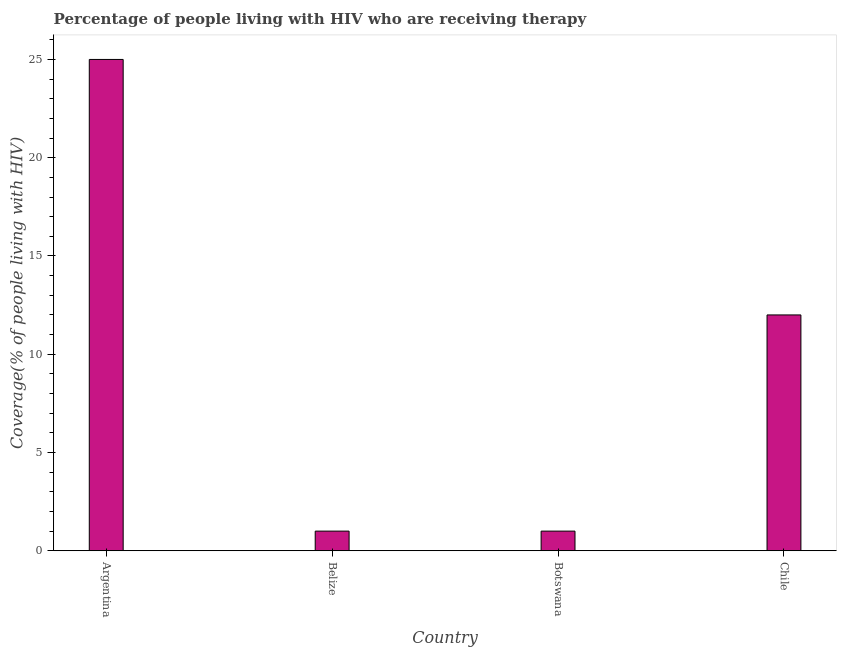Does the graph contain any zero values?
Offer a terse response. No. What is the title of the graph?
Your answer should be compact. Percentage of people living with HIV who are receiving therapy. What is the label or title of the X-axis?
Make the answer very short. Country. What is the label or title of the Y-axis?
Offer a very short reply. Coverage(% of people living with HIV). Across all countries, what is the maximum antiretroviral therapy coverage?
Provide a succinct answer. 25. Across all countries, what is the minimum antiretroviral therapy coverage?
Keep it short and to the point. 1. In which country was the antiretroviral therapy coverage maximum?
Provide a succinct answer. Argentina. In which country was the antiretroviral therapy coverage minimum?
Provide a short and direct response. Belize. What is the sum of the antiretroviral therapy coverage?
Your response must be concise. 39. What is the difference between the antiretroviral therapy coverage in Botswana and Chile?
Offer a terse response. -11. What is the average antiretroviral therapy coverage per country?
Keep it short and to the point. 9.75. In how many countries, is the antiretroviral therapy coverage greater than 22 %?
Offer a very short reply. 1. What is the ratio of the antiretroviral therapy coverage in Botswana to that in Chile?
Provide a succinct answer. 0.08. Is the antiretroviral therapy coverage in Botswana less than that in Chile?
Your answer should be compact. Yes. Is the sum of the antiretroviral therapy coverage in Belize and Chile greater than the maximum antiretroviral therapy coverage across all countries?
Ensure brevity in your answer.  No. In how many countries, is the antiretroviral therapy coverage greater than the average antiretroviral therapy coverage taken over all countries?
Ensure brevity in your answer.  2. How many countries are there in the graph?
Keep it short and to the point. 4. What is the difference between two consecutive major ticks on the Y-axis?
Your response must be concise. 5. What is the Coverage(% of people living with HIV) in Argentina?
Your response must be concise. 25. What is the Coverage(% of people living with HIV) of Botswana?
Offer a terse response. 1. What is the difference between the Coverage(% of people living with HIV) in Argentina and Belize?
Provide a short and direct response. 24. What is the difference between the Coverage(% of people living with HIV) in Argentina and Botswana?
Give a very brief answer. 24. What is the difference between the Coverage(% of people living with HIV) in Argentina and Chile?
Your answer should be compact. 13. What is the difference between the Coverage(% of people living with HIV) in Belize and Botswana?
Offer a terse response. 0. What is the difference between the Coverage(% of people living with HIV) in Belize and Chile?
Keep it short and to the point. -11. What is the difference between the Coverage(% of people living with HIV) in Botswana and Chile?
Your answer should be very brief. -11. What is the ratio of the Coverage(% of people living with HIV) in Argentina to that in Botswana?
Offer a very short reply. 25. What is the ratio of the Coverage(% of people living with HIV) in Argentina to that in Chile?
Make the answer very short. 2.08. What is the ratio of the Coverage(% of people living with HIV) in Belize to that in Botswana?
Your response must be concise. 1. What is the ratio of the Coverage(% of people living with HIV) in Belize to that in Chile?
Make the answer very short. 0.08. What is the ratio of the Coverage(% of people living with HIV) in Botswana to that in Chile?
Offer a terse response. 0.08. 